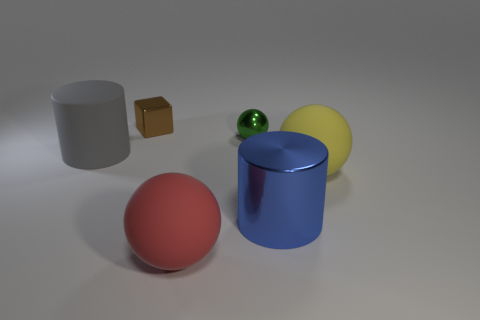Subtract all big red matte balls. How many balls are left? 2 Add 4 big brown matte balls. How many objects exist? 10 Subtract 1 balls. How many balls are left? 2 Subtract all red spheres. How many spheres are left? 2 Subtract all green spheres. Subtract all blue cubes. How many spheres are left? 2 Subtract all cyan balls. How many blue cylinders are left? 1 Subtract all small brown objects. Subtract all yellow rubber objects. How many objects are left? 4 Add 3 small green shiny things. How many small green shiny things are left? 4 Add 5 large yellow rubber cylinders. How many large yellow rubber cylinders exist? 5 Subtract 1 yellow spheres. How many objects are left? 5 